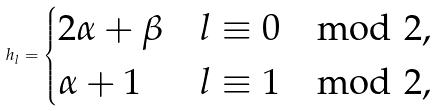Convert formula to latex. <formula><loc_0><loc_0><loc_500><loc_500>h _ { l } = \begin{cases} 2 \alpha + \beta & l \equiv 0 \mod 2 , \\ \alpha + 1 & l \equiv 1 \mod 2 , \end{cases}</formula> 